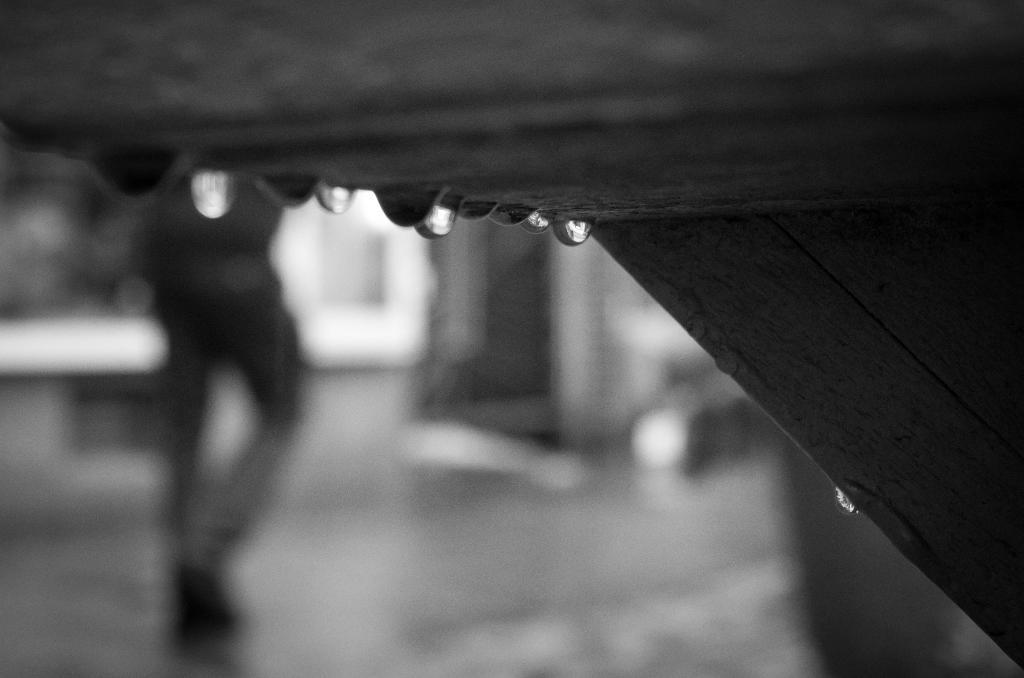What is the color scheme of the image? The image is black and white. What can be seen in the image besides the color scheme? There are water drops and a wooden object visible in the image. Can you describe the wooden object in the image? Unfortunately, the facts provided do not give enough information to describe the wooden object in detail. Is there any indication of a person in the image? There may be a person standing in the background of the image, but the facts provided do not confirm this. What type of cracker is the governor eating in the image? There is no cracker or governor present in the image. What is the office setting like in the image? There is no office setting present in the image. 